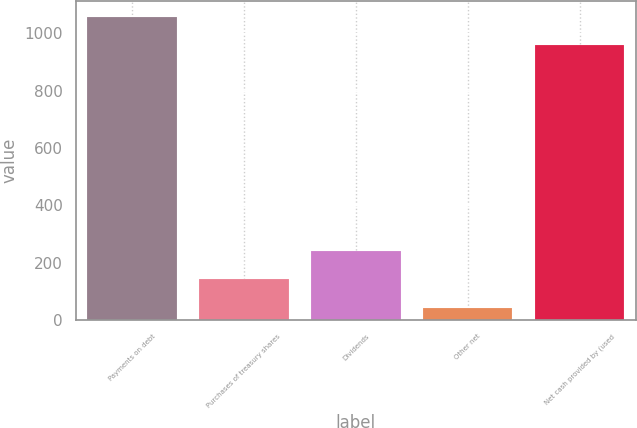<chart> <loc_0><loc_0><loc_500><loc_500><bar_chart><fcel>Payments on debt<fcel>Purchases of treasury shares<fcel>Dividends<fcel>Other net<fcel>Net cash provided by (used<nl><fcel>1058.2<fcel>141.2<fcel>240.4<fcel>42<fcel>959<nl></chart> 